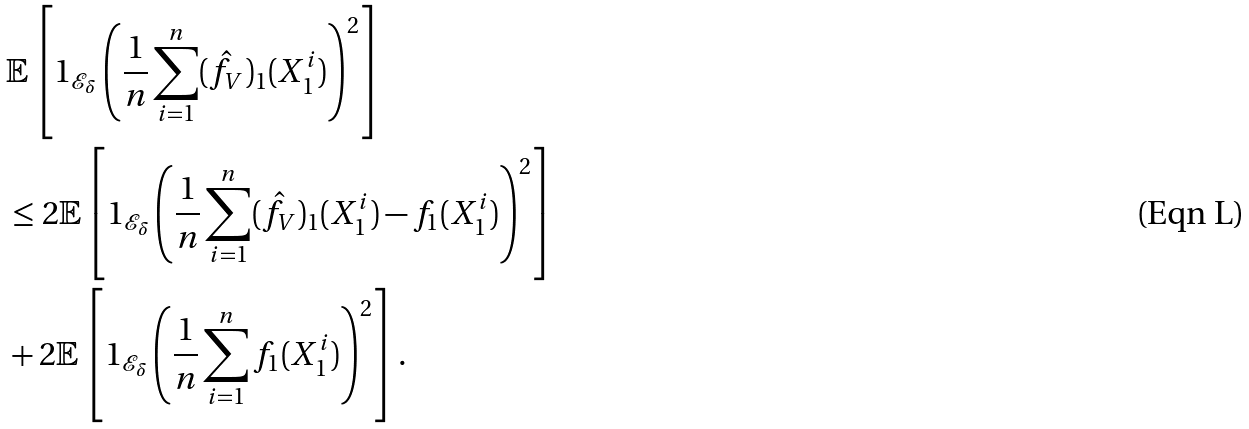<formula> <loc_0><loc_0><loc_500><loc_500>& \mathbb { E } \left [ 1 _ { \mathcal { E } _ { \delta } } \left ( \frac { 1 } { n } \sum _ { i = 1 } ^ { n } ( \hat { f } _ { V } ) _ { 1 } ( X _ { 1 } ^ { i } ) \right ) ^ { 2 } \right ] \\ & \leq 2 \mathbb { E } \left [ 1 _ { \mathcal { E } _ { \delta } } \left ( \frac { 1 } { n } \sum _ { i = 1 } ^ { n } ( \hat { f } _ { V } ) _ { 1 } ( X _ { 1 } ^ { i } ) - f _ { 1 } ( X _ { 1 } ^ { i } ) \right ) ^ { 2 } \right ] \\ & + 2 \mathbb { E } \left [ 1 _ { \mathcal { E } _ { \delta } } \left ( \frac { 1 } { n } \sum _ { i = 1 } ^ { n } f _ { 1 } ( X _ { 1 } ^ { i } ) \right ) ^ { 2 } \right ] .</formula> 